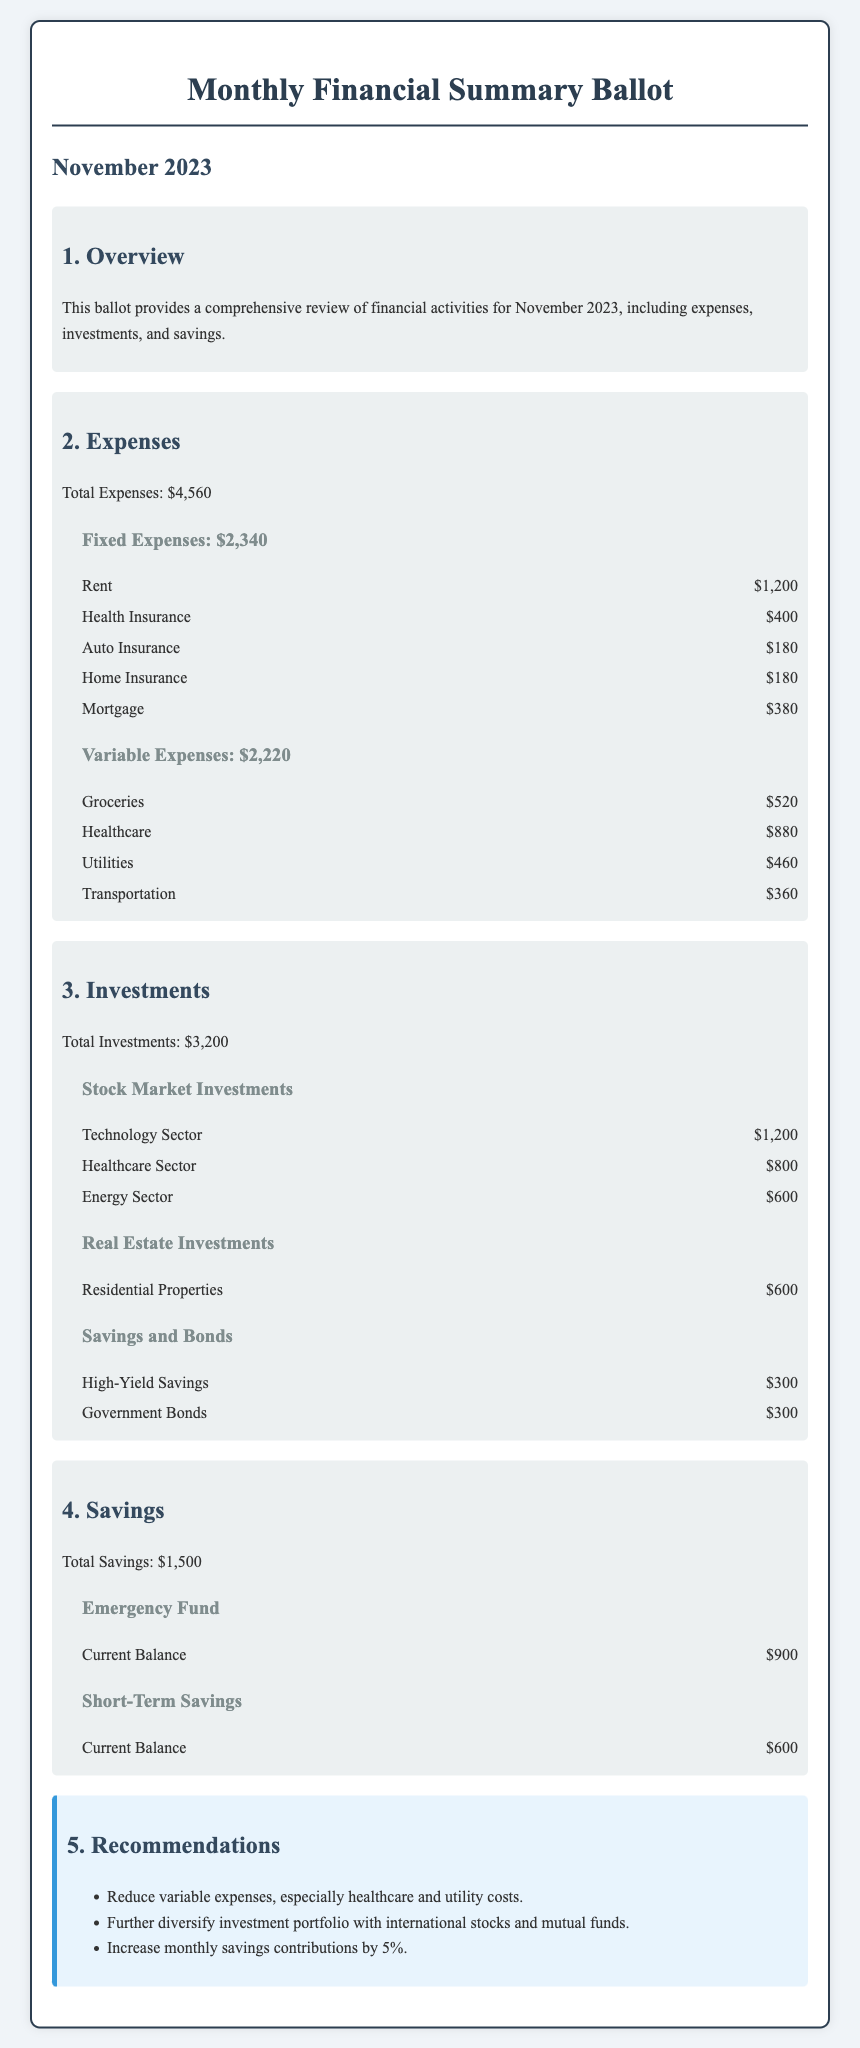What is the total expenses for November 2023? The document states that the total expenses for November 2023 are presented clearly in the expenses section.
Answer: $4,560 What are the total fixed expenses? The fixed expenses are listed under the expenses section, with a specific total provided.
Answer: $2,340 How much was spent on groceries? Groceries are listed as a variable expense in the document with a specific amount.
Answer: $520 What is the current balance of the emergency fund? The emergency fund's current balance is outlined in the savings section of the document.
Answer: $900 Which sector had the highest investment amount? Investments are categorized, and the one with the highest amount is indicated in the investments section.
Answer: Technology Sector What percentage of the total expenses are fixed expenses? This requires calculation to determine the fixed expenses' ratio to total expenses as indicated in the document.
Answer: 51.3% What is the total amount invested in the healthcare sector? The document specifies the exact investment amounts for each sector, including healthcare.
Answer: $800 How many categories are listed under variable expenses? The variable expenses subsection lists different categories to understand the total breakdown provided.
Answer: 4 What recommendation suggests increasing contributions? The recommendations section explicitly indicates increasing contributions in one of the suggestions listed.
Answer: Increase monthly savings contributions by 5% 